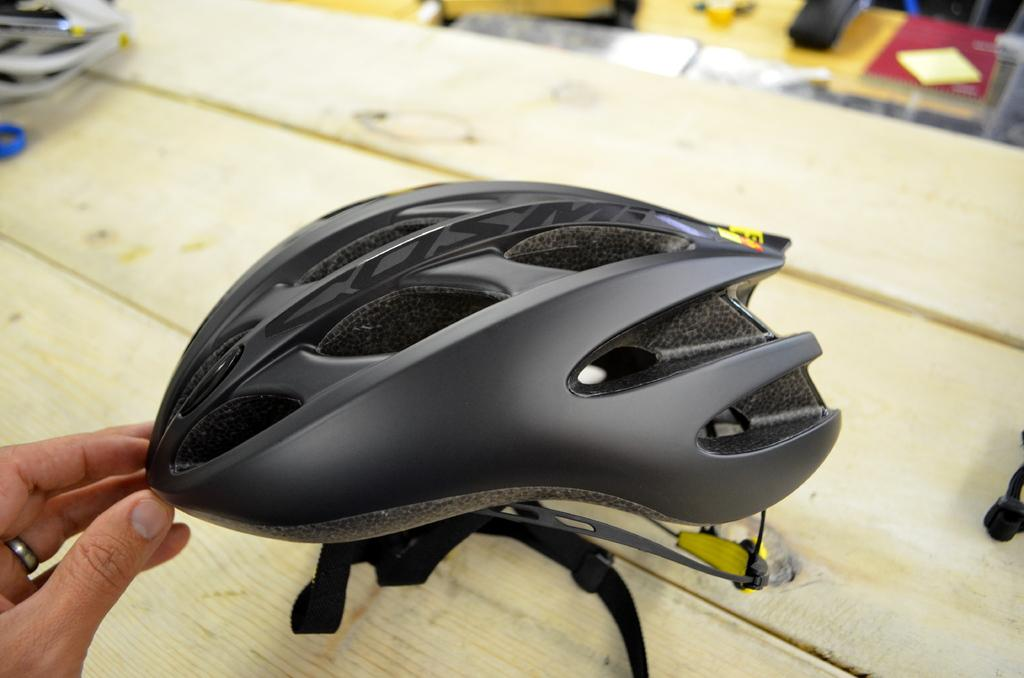What color is the helmet in the image? The helmet in the image is black. What is the surface of the table where the helmet is placed? The table is made of wood. What else can be seen on the table besides the helmet? There are other objects on the wooden table in the image. Whose hand is visible in the image? A person's hand is visible in the image. How many family members are present in the image? There is no information about family members in the image. 